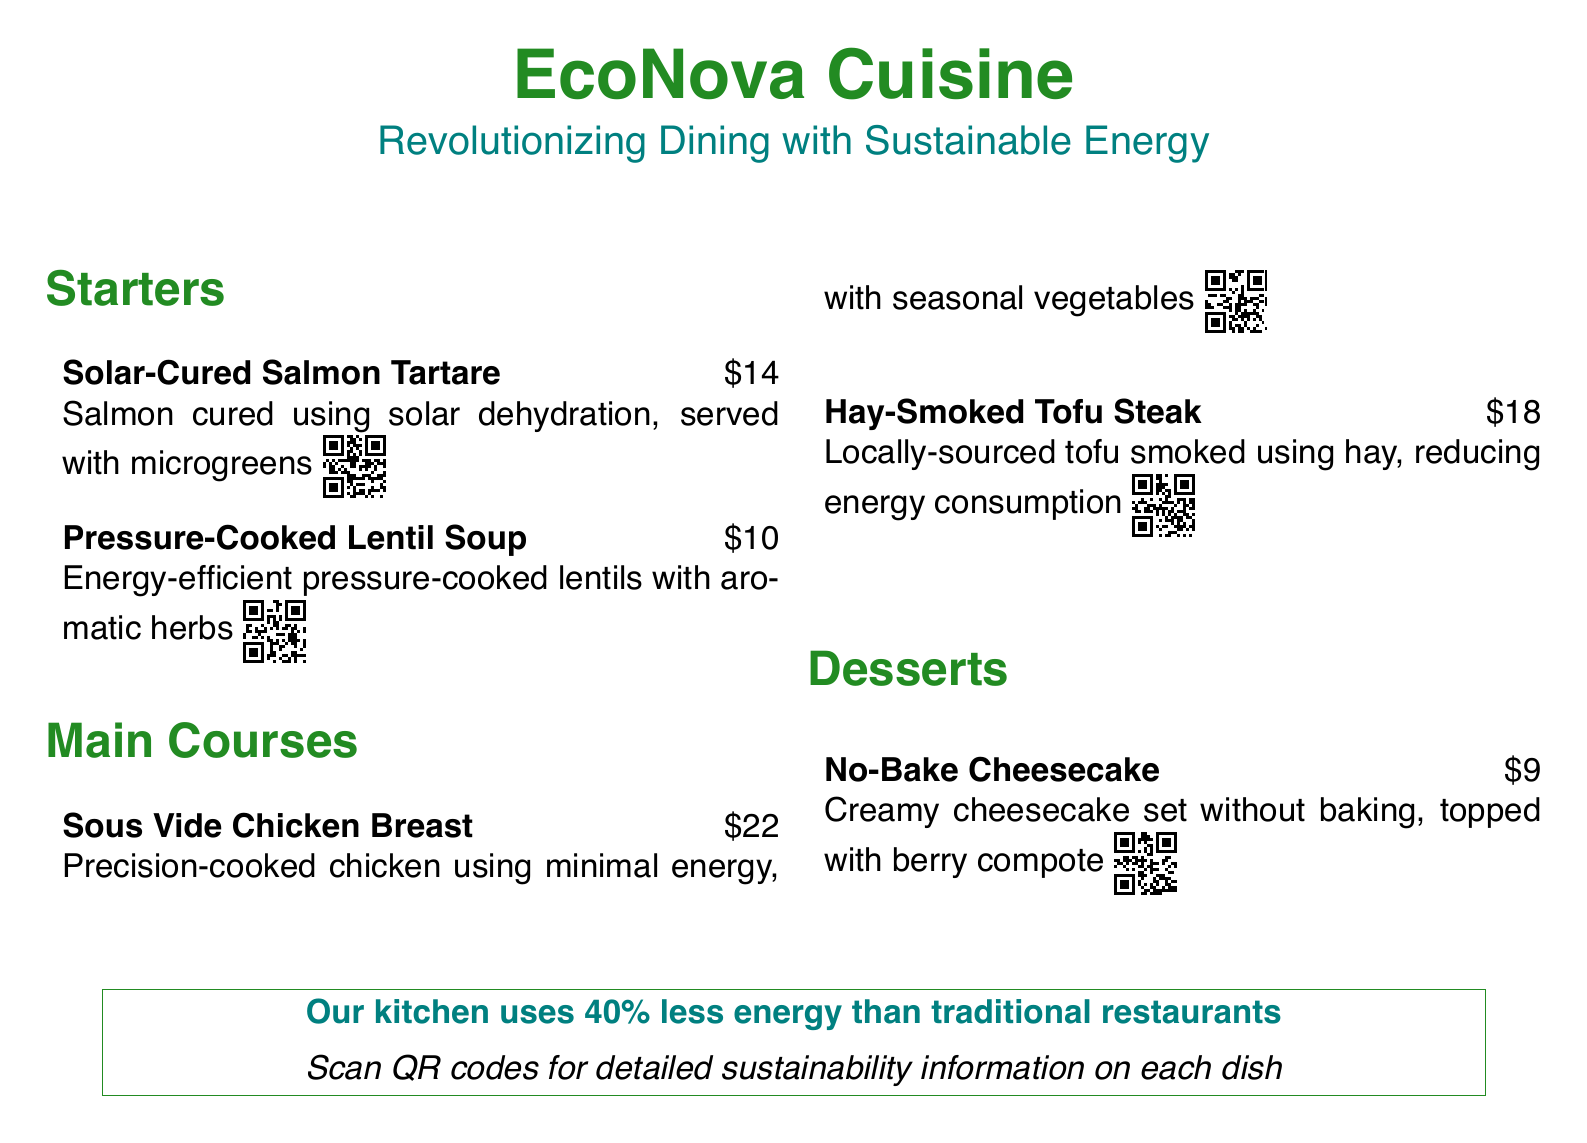What is the name of the first starter? The first starter is listed as "Solar-Cured Salmon Tartare" in the menu.
Answer: Solar-Cured Salmon Tartare How much does the Hay-Smoked Tofu Steak cost? The menu states the price of the Hay-Smoked Tofu Steak as $18.
Answer: $18 What cooking technique is used for the chicken dish? The menu specifies that the chicken breast is prepared using "Sous Vide," which is a cooking technique that maintains precision with minimal energy.
Answer: Sous Vide What is the energy reduction percentage of the kitchen compared to traditional restaurants? The document claims that the kitchen uses 40% less energy than traditional restaurants.
Answer: 40% What type of soup is offered as a starter? The menu features "Pressure-Cooked Lentil Soup" as one of the starters.
Answer: Pressure-Cooked Lentil Soup Which dish is described as having no baking involved? The dessert section mentions a "No-Bake Cheesecake" that does not require baking.
Answer: No-Bake Cheesecake What sustainability feature is linked to the smoked tofu? The document mentions that the Hay-Smoked Tofu Steak is made from locally-sourced tofu that reduces energy consumption.
Answer: Locally-sourced tofu How are customers encouraged to learn more about each dish? The document suggests scanning QR codes provided with each dish for detailed sustainability information.
Answer: QR codes 